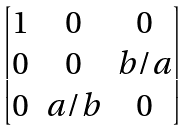<formula> <loc_0><loc_0><loc_500><loc_500>\begin{bmatrix} 1 & 0 & 0 \\ 0 & 0 & b / a \\ 0 & a / b & 0 \\ \end{bmatrix}</formula> 